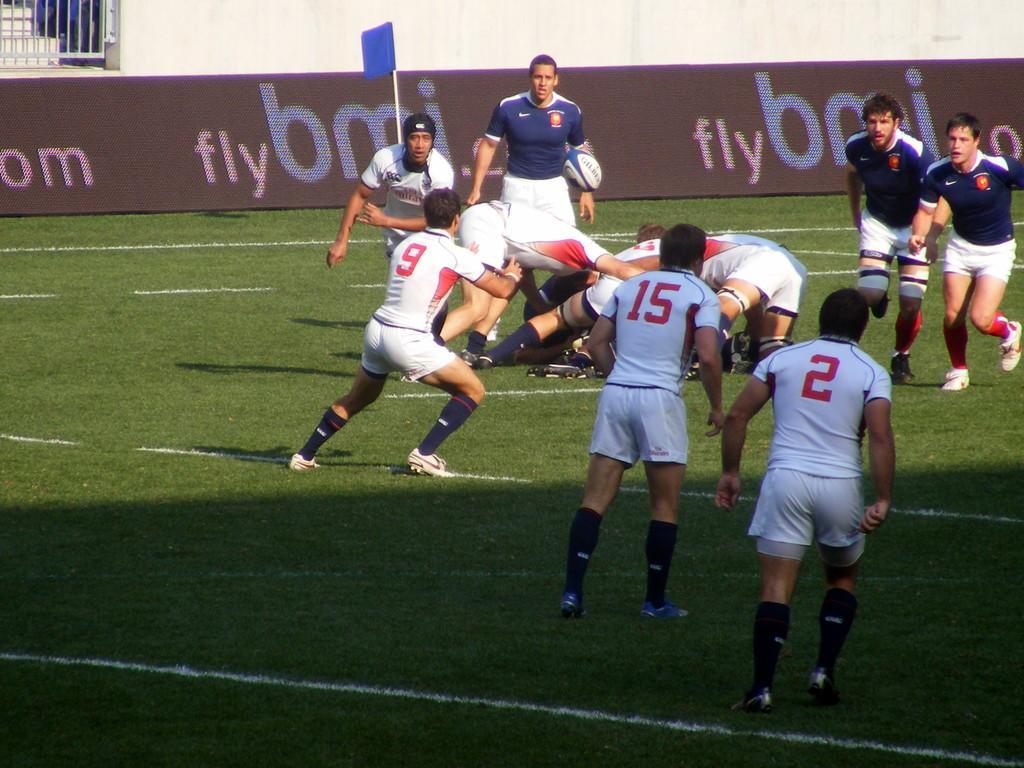In one or two sentences, can you explain what this image depicts? In the center of the image we can see a group of persons are there. At the top of the image we can see board, flag, wall, stairs are there. In the background of the image ground is present. 